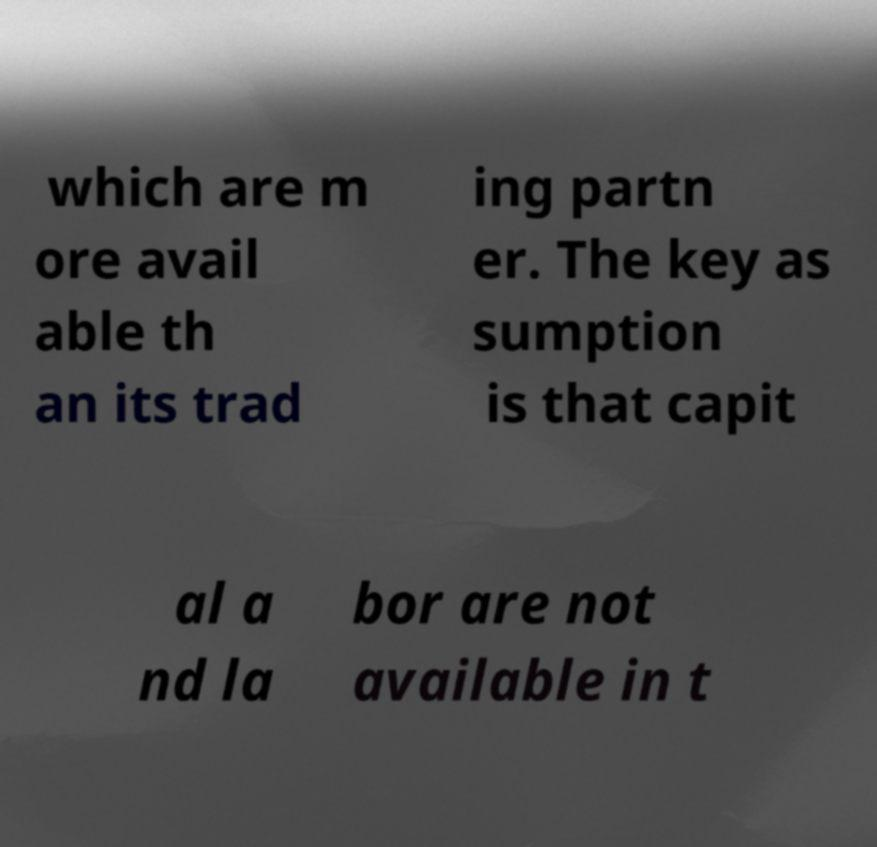Can you accurately transcribe the text from the provided image for me? which are m ore avail able th an its trad ing partn er. The key as sumption is that capit al a nd la bor are not available in t 